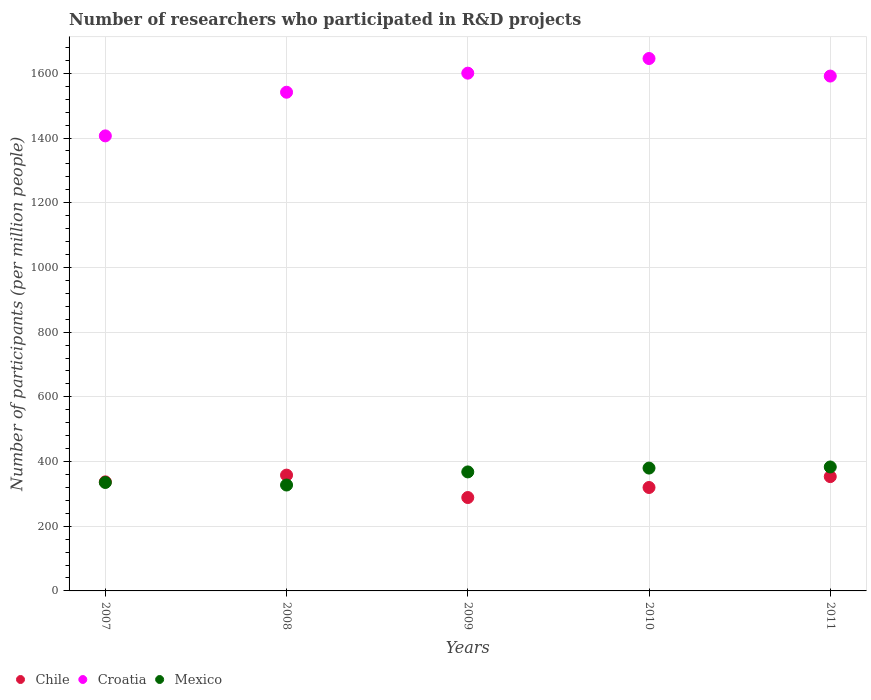How many different coloured dotlines are there?
Make the answer very short. 3. What is the number of researchers who participated in R&D projects in Chile in 2009?
Your answer should be compact. 288.71. Across all years, what is the maximum number of researchers who participated in R&D projects in Chile?
Your response must be concise. 357.99. Across all years, what is the minimum number of researchers who participated in R&D projects in Croatia?
Your answer should be very brief. 1406.67. In which year was the number of researchers who participated in R&D projects in Croatia minimum?
Your response must be concise. 2007. What is the total number of researchers who participated in R&D projects in Chile in the graph?
Provide a short and direct response. 1656.97. What is the difference between the number of researchers who participated in R&D projects in Mexico in 2008 and that in 2009?
Provide a short and direct response. -40.49. What is the difference between the number of researchers who participated in R&D projects in Croatia in 2007 and the number of researchers who participated in R&D projects in Chile in 2008?
Provide a short and direct response. 1048.68. What is the average number of researchers who participated in R&D projects in Chile per year?
Provide a succinct answer. 331.39. In the year 2010, what is the difference between the number of researchers who participated in R&D projects in Chile and number of researchers who participated in R&D projects in Croatia?
Ensure brevity in your answer.  -1326.09. What is the ratio of the number of researchers who participated in R&D projects in Croatia in 2007 to that in 2009?
Your response must be concise. 0.88. What is the difference between the highest and the second highest number of researchers who participated in R&D projects in Croatia?
Give a very brief answer. 45.26. What is the difference between the highest and the lowest number of researchers who participated in R&D projects in Mexico?
Your answer should be compact. 55.84. Does the number of researchers who participated in R&D projects in Chile monotonically increase over the years?
Keep it short and to the point. No. Is the number of researchers who participated in R&D projects in Chile strictly greater than the number of researchers who participated in R&D projects in Croatia over the years?
Your answer should be compact. No. How many dotlines are there?
Keep it short and to the point. 3. Does the graph contain grids?
Provide a succinct answer. Yes. Where does the legend appear in the graph?
Your response must be concise. Bottom left. How many legend labels are there?
Your answer should be compact. 3. How are the legend labels stacked?
Keep it short and to the point. Horizontal. What is the title of the graph?
Your answer should be very brief. Number of researchers who participated in R&D projects. What is the label or title of the X-axis?
Your answer should be compact. Years. What is the label or title of the Y-axis?
Offer a very short reply. Number of participants (per million people). What is the Number of participants (per million people) of Chile in 2007?
Provide a succinct answer. 337.18. What is the Number of participants (per million people) of Croatia in 2007?
Your response must be concise. 1406.67. What is the Number of participants (per million people) of Mexico in 2007?
Your response must be concise. 335.25. What is the Number of participants (per million people) in Chile in 2008?
Give a very brief answer. 357.99. What is the Number of participants (per million people) in Croatia in 2008?
Keep it short and to the point. 1541.61. What is the Number of participants (per million people) in Mexico in 2008?
Your answer should be very brief. 327.37. What is the Number of participants (per million people) in Chile in 2009?
Give a very brief answer. 288.71. What is the Number of participants (per million people) of Croatia in 2009?
Make the answer very short. 1600.55. What is the Number of participants (per million people) of Mexico in 2009?
Give a very brief answer. 367.87. What is the Number of participants (per million people) of Chile in 2010?
Your answer should be very brief. 319.72. What is the Number of participants (per million people) in Croatia in 2010?
Your answer should be very brief. 1645.81. What is the Number of participants (per million people) in Mexico in 2010?
Make the answer very short. 379.75. What is the Number of participants (per million people) of Chile in 2011?
Your answer should be compact. 353.37. What is the Number of participants (per million people) of Croatia in 2011?
Provide a short and direct response. 1591.56. What is the Number of participants (per million people) in Mexico in 2011?
Provide a short and direct response. 383.21. Across all years, what is the maximum Number of participants (per million people) of Chile?
Keep it short and to the point. 357.99. Across all years, what is the maximum Number of participants (per million people) in Croatia?
Make the answer very short. 1645.81. Across all years, what is the maximum Number of participants (per million people) in Mexico?
Provide a short and direct response. 383.21. Across all years, what is the minimum Number of participants (per million people) of Chile?
Provide a succinct answer. 288.71. Across all years, what is the minimum Number of participants (per million people) in Croatia?
Your answer should be very brief. 1406.67. Across all years, what is the minimum Number of participants (per million people) of Mexico?
Provide a succinct answer. 327.37. What is the total Number of participants (per million people) of Chile in the graph?
Provide a succinct answer. 1656.97. What is the total Number of participants (per million people) in Croatia in the graph?
Offer a terse response. 7786.19. What is the total Number of participants (per million people) in Mexico in the graph?
Ensure brevity in your answer.  1793.45. What is the difference between the Number of participants (per million people) of Chile in 2007 and that in 2008?
Your response must be concise. -20.81. What is the difference between the Number of participants (per million people) of Croatia in 2007 and that in 2008?
Provide a short and direct response. -134.95. What is the difference between the Number of participants (per million people) of Mexico in 2007 and that in 2008?
Keep it short and to the point. 7.88. What is the difference between the Number of participants (per million people) of Chile in 2007 and that in 2009?
Make the answer very short. 48.47. What is the difference between the Number of participants (per million people) of Croatia in 2007 and that in 2009?
Offer a very short reply. -193.88. What is the difference between the Number of participants (per million people) of Mexico in 2007 and that in 2009?
Your answer should be very brief. -32.62. What is the difference between the Number of participants (per million people) in Chile in 2007 and that in 2010?
Your response must be concise. 17.47. What is the difference between the Number of participants (per million people) of Croatia in 2007 and that in 2010?
Give a very brief answer. -239.14. What is the difference between the Number of participants (per million people) in Mexico in 2007 and that in 2010?
Provide a succinct answer. -44.5. What is the difference between the Number of participants (per million people) in Chile in 2007 and that in 2011?
Your answer should be compact. -16.19. What is the difference between the Number of participants (per million people) in Croatia in 2007 and that in 2011?
Your answer should be very brief. -184.89. What is the difference between the Number of participants (per million people) of Mexico in 2007 and that in 2011?
Your answer should be compact. -47.96. What is the difference between the Number of participants (per million people) in Chile in 2008 and that in 2009?
Your response must be concise. 69.28. What is the difference between the Number of participants (per million people) of Croatia in 2008 and that in 2009?
Offer a very short reply. -58.93. What is the difference between the Number of participants (per million people) in Mexico in 2008 and that in 2009?
Ensure brevity in your answer.  -40.49. What is the difference between the Number of participants (per million people) of Chile in 2008 and that in 2010?
Give a very brief answer. 38.27. What is the difference between the Number of participants (per million people) of Croatia in 2008 and that in 2010?
Give a very brief answer. -104.19. What is the difference between the Number of participants (per million people) of Mexico in 2008 and that in 2010?
Give a very brief answer. -52.38. What is the difference between the Number of participants (per million people) in Chile in 2008 and that in 2011?
Give a very brief answer. 4.62. What is the difference between the Number of participants (per million people) of Croatia in 2008 and that in 2011?
Offer a terse response. -49.95. What is the difference between the Number of participants (per million people) of Mexico in 2008 and that in 2011?
Give a very brief answer. -55.84. What is the difference between the Number of participants (per million people) of Chile in 2009 and that in 2010?
Ensure brevity in your answer.  -31.01. What is the difference between the Number of participants (per million people) of Croatia in 2009 and that in 2010?
Your response must be concise. -45.26. What is the difference between the Number of participants (per million people) in Mexico in 2009 and that in 2010?
Your response must be concise. -11.88. What is the difference between the Number of participants (per million people) in Chile in 2009 and that in 2011?
Keep it short and to the point. -64.66. What is the difference between the Number of participants (per million people) in Croatia in 2009 and that in 2011?
Your answer should be compact. 8.99. What is the difference between the Number of participants (per million people) in Mexico in 2009 and that in 2011?
Keep it short and to the point. -15.34. What is the difference between the Number of participants (per million people) of Chile in 2010 and that in 2011?
Your response must be concise. -33.65. What is the difference between the Number of participants (per million people) in Croatia in 2010 and that in 2011?
Make the answer very short. 54.25. What is the difference between the Number of participants (per million people) of Mexico in 2010 and that in 2011?
Ensure brevity in your answer.  -3.46. What is the difference between the Number of participants (per million people) of Chile in 2007 and the Number of participants (per million people) of Croatia in 2008?
Give a very brief answer. -1204.43. What is the difference between the Number of participants (per million people) of Chile in 2007 and the Number of participants (per million people) of Mexico in 2008?
Offer a very short reply. 9.81. What is the difference between the Number of participants (per million people) of Croatia in 2007 and the Number of participants (per million people) of Mexico in 2008?
Give a very brief answer. 1079.29. What is the difference between the Number of participants (per million people) in Chile in 2007 and the Number of participants (per million people) in Croatia in 2009?
Your response must be concise. -1263.36. What is the difference between the Number of participants (per million people) of Chile in 2007 and the Number of participants (per million people) of Mexico in 2009?
Offer a terse response. -30.68. What is the difference between the Number of participants (per million people) of Croatia in 2007 and the Number of participants (per million people) of Mexico in 2009?
Your answer should be compact. 1038.8. What is the difference between the Number of participants (per million people) in Chile in 2007 and the Number of participants (per million people) in Croatia in 2010?
Offer a very short reply. -1308.62. What is the difference between the Number of participants (per million people) in Chile in 2007 and the Number of participants (per million people) in Mexico in 2010?
Provide a short and direct response. -42.56. What is the difference between the Number of participants (per million people) of Croatia in 2007 and the Number of participants (per million people) of Mexico in 2010?
Keep it short and to the point. 1026.92. What is the difference between the Number of participants (per million people) of Chile in 2007 and the Number of participants (per million people) of Croatia in 2011?
Ensure brevity in your answer.  -1254.38. What is the difference between the Number of participants (per million people) of Chile in 2007 and the Number of participants (per million people) of Mexico in 2011?
Your answer should be very brief. -46.03. What is the difference between the Number of participants (per million people) of Croatia in 2007 and the Number of participants (per million people) of Mexico in 2011?
Your response must be concise. 1023.46. What is the difference between the Number of participants (per million people) in Chile in 2008 and the Number of participants (per million people) in Croatia in 2009?
Give a very brief answer. -1242.56. What is the difference between the Number of participants (per million people) in Chile in 2008 and the Number of participants (per million people) in Mexico in 2009?
Give a very brief answer. -9.88. What is the difference between the Number of participants (per million people) of Croatia in 2008 and the Number of participants (per million people) of Mexico in 2009?
Provide a succinct answer. 1173.75. What is the difference between the Number of participants (per million people) in Chile in 2008 and the Number of participants (per million people) in Croatia in 2010?
Your response must be concise. -1287.82. What is the difference between the Number of participants (per million people) of Chile in 2008 and the Number of participants (per million people) of Mexico in 2010?
Your answer should be compact. -21.76. What is the difference between the Number of participants (per million people) in Croatia in 2008 and the Number of participants (per million people) in Mexico in 2010?
Offer a terse response. 1161.87. What is the difference between the Number of participants (per million people) of Chile in 2008 and the Number of participants (per million people) of Croatia in 2011?
Offer a very short reply. -1233.57. What is the difference between the Number of participants (per million people) in Chile in 2008 and the Number of participants (per million people) in Mexico in 2011?
Your answer should be compact. -25.22. What is the difference between the Number of participants (per million people) of Croatia in 2008 and the Number of participants (per million people) of Mexico in 2011?
Offer a terse response. 1158.4. What is the difference between the Number of participants (per million people) in Chile in 2009 and the Number of participants (per million people) in Croatia in 2010?
Make the answer very short. -1357.1. What is the difference between the Number of participants (per million people) in Chile in 2009 and the Number of participants (per million people) in Mexico in 2010?
Ensure brevity in your answer.  -91.04. What is the difference between the Number of participants (per million people) of Croatia in 2009 and the Number of participants (per million people) of Mexico in 2010?
Ensure brevity in your answer.  1220.8. What is the difference between the Number of participants (per million people) of Chile in 2009 and the Number of participants (per million people) of Croatia in 2011?
Ensure brevity in your answer.  -1302.85. What is the difference between the Number of participants (per million people) of Chile in 2009 and the Number of participants (per million people) of Mexico in 2011?
Give a very brief answer. -94.5. What is the difference between the Number of participants (per million people) in Croatia in 2009 and the Number of participants (per million people) in Mexico in 2011?
Offer a very short reply. 1217.34. What is the difference between the Number of participants (per million people) of Chile in 2010 and the Number of participants (per million people) of Croatia in 2011?
Your answer should be very brief. -1271.84. What is the difference between the Number of participants (per million people) of Chile in 2010 and the Number of participants (per million people) of Mexico in 2011?
Your response must be concise. -63.49. What is the difference between the Number of participants (per million people) of Croatia in 2010 and the Number of participants (per million people) of Mexico in 2011?
Keep it short and to the point. 1262.6. What is the average Number of participants (per million people) in Chile per year?
Provide a succinct answer. 331.39. What is the average Number of participants (per million people) in Croatia per year?
Your answer should be very brief. 1557.24. What is the average Number of participants (per million people) in Mexico per year?
Provide a succinct answer. 358.69. In the year 2007, what is the difference between the Number of participants (per million people) in Chile and Number of participants (per million people) in Croatia?
Make the answer very short. -1069.48. In the year 2007, what is the difference between the Number of participants (per million people) of Chile and Number of participants (per million people) of Mexico?
Keep it short and to the point. 1.93. In the year 2007, what is the difference between the Number of participants (per million people) of Croatia and Number of participants (per million people) of Mexico?
Your response must be concise. 1071.41. In the year 2008, what is the difference between the Number of participants (per million people) of Chile and Number of participants (per million people) of Croatia?
Provide a succinct answer. -1183.62. In the year 2008, what is the difference between the Number of participants (per million people) of Chile and Number of participants (per million people) of Mexico?
Provide a short and direct response. 30.62. In the year 2008, what is the difference between the Number of participants (per million people) of Croatia and Number of participants (per million people) of Mexico?
Ensure brevity in your answer.  1214.24. In the year 2009, what is the difference between the Number of participants (per million people) of Chile and Number of participants (per million people) of Croatia?
Offer a terse response. -1311.83. In the year 2009, what is the difference between the Number of participants (per million people) in Chile and Number of participants (per million people) in Mexico?
Give a very brief answer. -79.16. In the year 2009, what is the difference between the Number of participants (per million people) of Croatia and Number of participants (per million people) of Mexico?
Make the answer very short. 1232.68. In the year 2010, what is the difference between the Number of participants (per million people) in Chile and Number of participants (per million people) in Croatia?
Your answer should be very brief. -1326.09. In the year 2010, what is the difference between the Number of participants (per million people) of Chile and Number of participants (per million people) of Mexico?
Give a very brief answer. -60.03. In the year 2010, what is the difference between the Number of participants (per million people) of Croatia and Number of participants (per million people) of Mexico?
Provide a short and direct response. 1266.06. In the year 2011, what is the difference between the Number of participants (per million people) of Chile and Number of participants (per million people) of Croatia?
Offer a very short reply. -1238.19. In the year 2011, what is the difference between the Number of participants (per million people) of Chile and Number of participants (per million people) of Mexico?
Give a very brief answer. -29.84. In the year 2011, what is the difference between the Number of participants (per million people) of Croatia and Number of participants (per million people) of Mexico?
Offer a very short reply. 1208.35. What is the ratio of the Number of participants (per million people) of Chile in 2007 to that in 2008?
Provide a succinct answer. 0.94. What is the ratio of the Number of participants (per million people) in Croatia in 2007 to that in 2008?
Make the answer very short. 0.91. What is the ratio of the Number of participants (per million people) in Mexico in 2007 to that in 2008?
Keep it short and to the point. 1.02. What is the ratio of the Number of participants (per million people) in Chile in 2007 to that in 2009?
Provide a succinct answer. 1.17. What is the ratio of the Number of participants (per million people) of Croatia in 2007 to that in 2009?
Your answer should be compact. 0.88. What is the ratio of the Number of participants (per million people) of Mexico in 2007 to that in 2009?
Your response must be concise. 0.91. What is the ratio of the Number of participants (per million people) of Chile in 2007 to that in 2010?
Your answer should be compact. 1.05. What is the ratio of the Number of participants (per million people) in Croatia in 2007 to that in 2010?
Your answer should be compact. 0.85. What is the ratio of the Number of participants (per million people) of Mexico in 2007 to that in 2010?
Make the answer very short. 0.88. What is the ratio of the Number of participants (per million people) in Chile in 2007 to that in 2011?
Provide a short and direct response. 0.95. What is the ratio of the Number of participants (per million people) of Croatia in 2007 to that in 2011?
Provide a succinct answer. 0.88. What is the ratio of the Number of participants (per million people) in Mexico in 2007 to that in 2011?
Provide a short and direct response. 0.87. What is the ratio of the Number of participants (per million people) in Chile in 2008 to that in 2009?
Your answer should be very brief. 1.24. What is the ratio of the Number of participants (per million people) of Croatia in 2008 to that in 2009?
Offer a terse response. 0.96. What is the ratio of the Number of participants (per million people) of Mexico in 2008 to that in 2009?
Keep it short and to the point. 0.89. What is the ratio of the Number of participants (per million people) of Chile in 2008 to that in 2010?
Your response must be concise. 1.12. What is the ratio of the Number of participants (per million people) of Croatia in 2008 to that in 2010?
Your response must be concise. 0.94. What is the ratio of the Number of participants (per million people) in Mexico in 2008 to that in 2010?
Give a very brief answer. 0.86. What is the ratio of the Number of participants (per million people) of Chile in 2008 to that in 2011?
Give a very brief answer. 1.01. What is the ratio of the Number of participants (per million people) in Croatia in 2008 to that in 2011?
Your answer should be compact. 0.97. What is the ratio of the Number of participants (per million people) in Mexico in 2008 to that in 2011?
Provide a succinct answer. 0.85. What is the ratio of the Number of participants (per million people) of Chile in 2009 to that in 2010?
Provide a short and direct response. 0.9. What is the ratio of the Number of participants (per million people) in Croatia in 2009 to that in 2010?
Keep it short and to the point. 0.97. What is the ratio of the Number of participants (per million people) of Mexico in 2009 to that in 2010?
Your answer should be compact. 0.97. What is the ratio of the Number of participants (per million people) of Chile in 2009 to that in 2011?
Offer a very short reply. 0.82. What is the ratio of the Number of participants (per million people) of Croatia in 2009 to that in 2011?
Ensure brevity in your answer.  1.01. What is the ratio of the Number of participants (per million people) in Chile in 2010 to that in 2011?
Your answer should be very brief. 0.9. What is the ratio of the Number of participants (per million people) of Croatia in 2010 to that in 2011?
Your answer should be compact. 1.03. What is the ratio of the Number of participants (per million people) of Mexico in 2010 to that in 2011?
Provide a short and direct response. 0.99. What is the difference between the highest and the second highest Number of participants (per million people) of Chile?
Provide a short and direct response. 4.62. What is the difference between the highest and the second highest Number of participants (per million people) of Croatia?
Your answer should be very brief. 45.26. What is the difference between the highest and the second highest Number of participants (per million people) of Mexico?
Make the answer very short. 3.46. What is the difference between the highest and the lowest Number of participants (per million people) in Chile?
Offer a very short reply. 69.28. What is the difference between the highest and the lowest Number of participants (per million people) in Croatia?
Offer a very short reply. 239.14. What is the difference between the highest and the lowest Number of participants (per million people) in Mexico?
Make the answer very short. 55.84. 